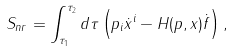Convert formula to latex. <formula><loc_0><loc_0><loc_500><loc_500>S _ { n r } = \int _ { \tau _ { 1 } } ^ { \tau _ { 2 } } d \tau \left ( p _ { i } \dot { x } ^ { i } - H ( { p , x } ) \dot { f } \right ) ,</formula> 